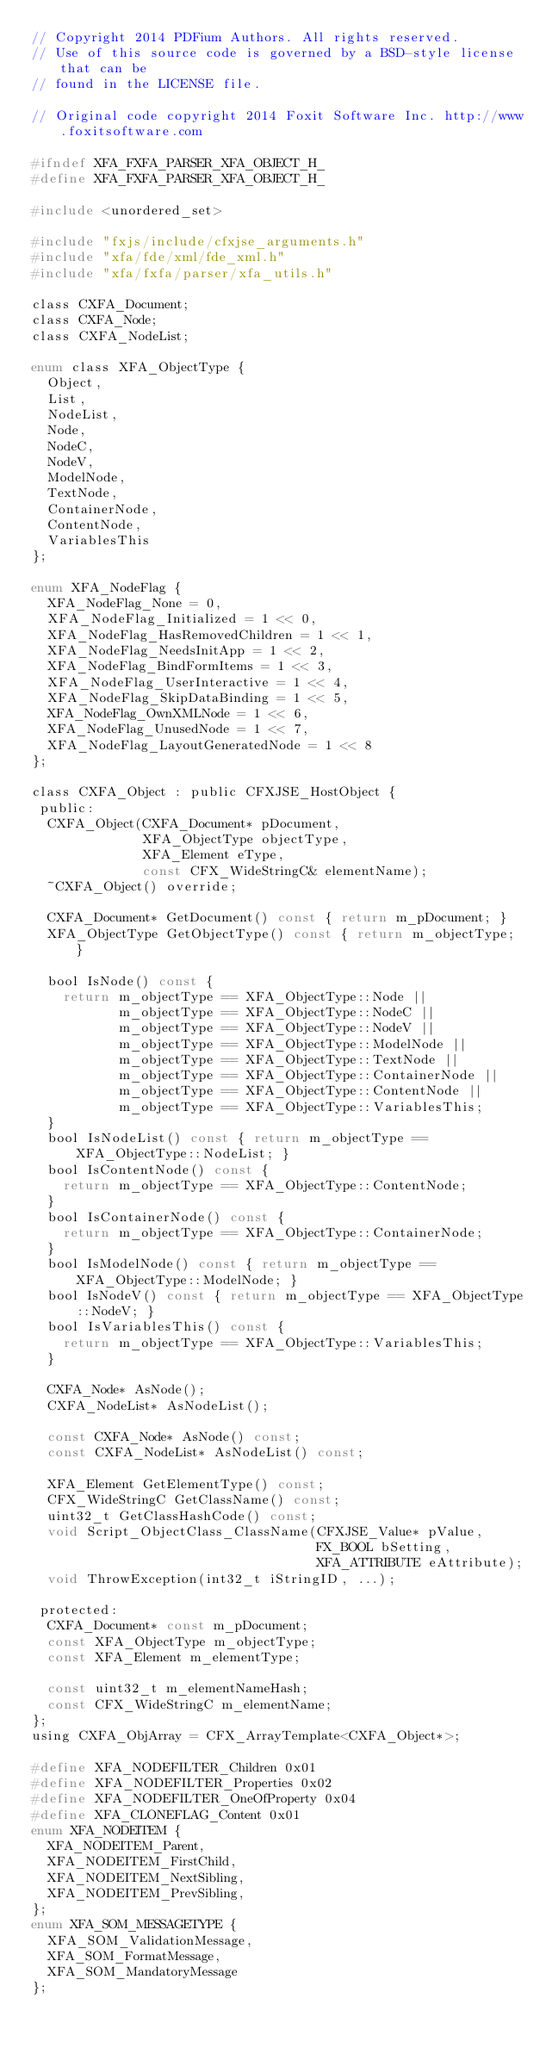<code> <loc_0><loc_0><loc_500><loc_500><_C_>// Copyright 2014 PDFium Authors. All rights reserved.
// Use of this source code is governed by a BSD-style license that can be
// found in the LICENSE file.

// Original code copyright 2014 Foxit Software Inc. http://www.foxitsoftware.com

#ifndef XFA_FXFA_PARSER_XFA_OBJECT_H_
#define XFA_FXFA_PARSER_XFA_OBJECT_H_

#include <unordered_set>

#include "fxjs/include/cfxjse_arguments.h"
#include "xfa/fde/xml/fde_xml.h"
#include "xfa/fxfa/parser/xfa_utils.h"

class CXFA_Document;
class CXFA_Node;
class CXFA_NodeList;

enum class XFA_ObjectType {
  Object,
  List,
  NodeList,
  Node,
  NodeC,
  NodeV,
  ModelNode,
  TextNode,
  ContainerNode,
  ContentNode,
  VariablesThis
};

enum XFA_NodeFlag {
  XFA_NodeFlag_None = 0,
  XFA_NodeFlag_Initialized = 1 << 0,
  XFA_NodeFlag_HasRemovedChildren = 1 << 1,
  XFA_NodeFlag_NeedsInitApp = 1 << 2,
  XFA_NodeFlag_BindFormItems = 1 << 3,
  XFA_NodeFlag_UserInteractive = 1 << 4,
  XFA_NodeFlag_SkipDataBinding = 1 << 5,
  XFA_NodeFlag_OwnXMLNode = 1 << 6,
  XFA_NodeFlag_UnusedNode = 1 << 7,
  XFA_NodeFlag_LayoutGeneratedNode = 1 << 8
};

class CXFA_Object : public CFXJSE_HostObject {
 public:
  CXFA_Object(CXFA_Document* pDocument,
              XFA_ObjectType objectType,
              XFA_Element eType,
              const CFX_WideStringC& elementName);
  ~CXFA_Object() override;

  CXFA_Document* GetDocument() const { return m_pDocument; }
  XFA_ObjectType GetObjectType() const { return m_objectType; }

  bool IsNode() const {
    return m_objectType == XFA_ObjectType::Node ||
           m_objectType == XFA_ObjectType::NodeC ||
           m_objectType == XFA_ObjectType::NodeV ||
           m_objectType == XFA_ObjectType::ModelNode ||
           m_objectType == XFA_ObjectType::TextNode ||
           m_objectType == XFA_ObjectType::ContainerNode ||
           m_objectType == XFA_ObjectType::ContentNode ||
           m_objectType == XFA_ObjectType::VariablesThis;
  }
  bool IsNodeList() const { return m_objectType == XFA_ObjectType::NodeList; }
  bool IsContentNode() const {
    return m_objectType == XFA_ObjectType::ContentNode;
  }
  bool IsContainerNode() const {
    return m_objectType == XFA_ObjectType::ContainerNode;
  }
  bool IsModelNode() const { return m_objectType == XFA_ObjectType::ModelNode; }
  bool IsNodeV() const { return m_objectType == XFA_ObjectType::NodeV; }
  bool IsVariablesThis() const {
    return m_objectType == XFA_ObjectType::VariablesThis;
  }

  CXFA_Node* AsNode();
  CXFA_NodeList* AsNodeList();

  const CXFA_Node* AsNode() const;
  const CXFA_NodeList* AsNodeList() const;

  XFA_Element GetElementType() const;
  CFX_WideStringC GetClassName() const;
  uint32_t GetClassHashCode() const;
  void Script_ObjectClass_ClassName(CFXJSE_Value* pValue,
                                    FX_BOOL bSetting,
                                    XFA_ATTRIBUTE eAttribute);
  void ThrowException(int32_t iStringID, ...);

 protected:
  CXFA_Document* const m_pDocument;
  const XFA_ObjectType m_objectType;
  const XFA_Element m_elementType;

  const uint32_t m_elementNameHash;
  const CFX_WideStringC m_elementName;
};
using CXFA_ObjArray = CFX_ArrayTemplate<CXFA_Object*>;

#define XFA_NODEFILTER_Children 0x01
#define XFA_NODEFILTER_Properties 0x02
#define XFA_NODEFILTER_OneOfProperty 0x04
#define XFA_CLONEFLAG_Content 0x01
enum XFA_NODEITEM {
  XFA_NODEITEM_Parent,
  XFA_NODEITEM_FirstChild,
  XFA_NODEITEM_NextSibling,
  XFA_NODEITEM_PrevSibling,
};
enum XFA_SOM_MESSAGETYPE {
  XFA_SOM_ValidationMessage,
  XFA_SOM_FormatMessage,
  XFA_SOM_MandatoryMessage
};
</code> 